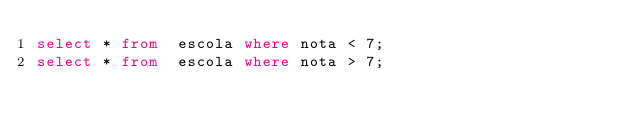<code> <loc_0><loc_0><loc_500><loc_500><_SQL_>select * from  escola where nota < 7;
select * from  escola where nota > 7;
</code> 